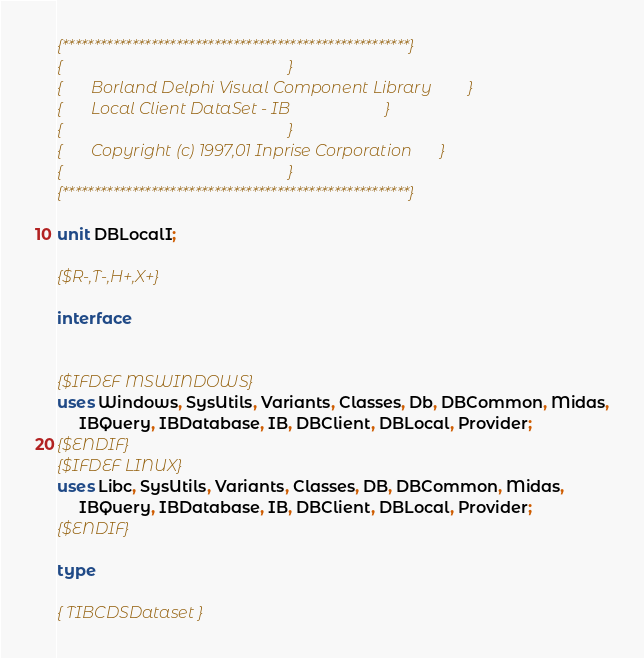<code> <loc_0><loc_0><loc_500><loc_500><_Pascal_>
{*******************************************************}
{                                                       }
{       Borland Delphi Visual Component Library         }
{       Local Client DataSet - IB                       }
{                                                       }
{       Copyright (c) 1997,01 Inprise Corporation       }
{                                                       }
{*******************************************************}

unit DBLocalI;

{$R-,T-,H+,X+}

interface


{$IFDEF MSWINDOWS}
uses Windows, SysUtils, Variants, Classes, Db, DBCommon, Midas,
     IBQuery, IBDatabase, IB, DBClient, DBLocal, Provider;
{$ENDIF}
{$IFDEF LINUX}
uses Libc, SysUtils, Variants, Classes, DB, DBCommon, Midas,
     IBQuery, IBDatabase, IB, DBClient, DBLocal, Provider;
{$ENDIF}

type
  
{ TIBCDSDataset }
</code> 